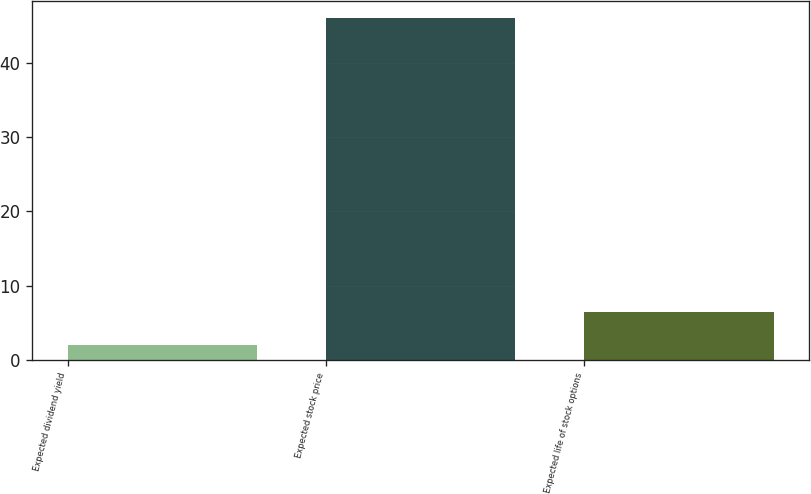Convert chart. <chart><loc_0><loc_0><loc_500><loc_500><bar_chart><fcel>Expected dividend yield<fcel>Expected stock price<fcel>Expected life of stock options<nl><fcel>2<fcel>46<fcel>6.4<nl></chart> 